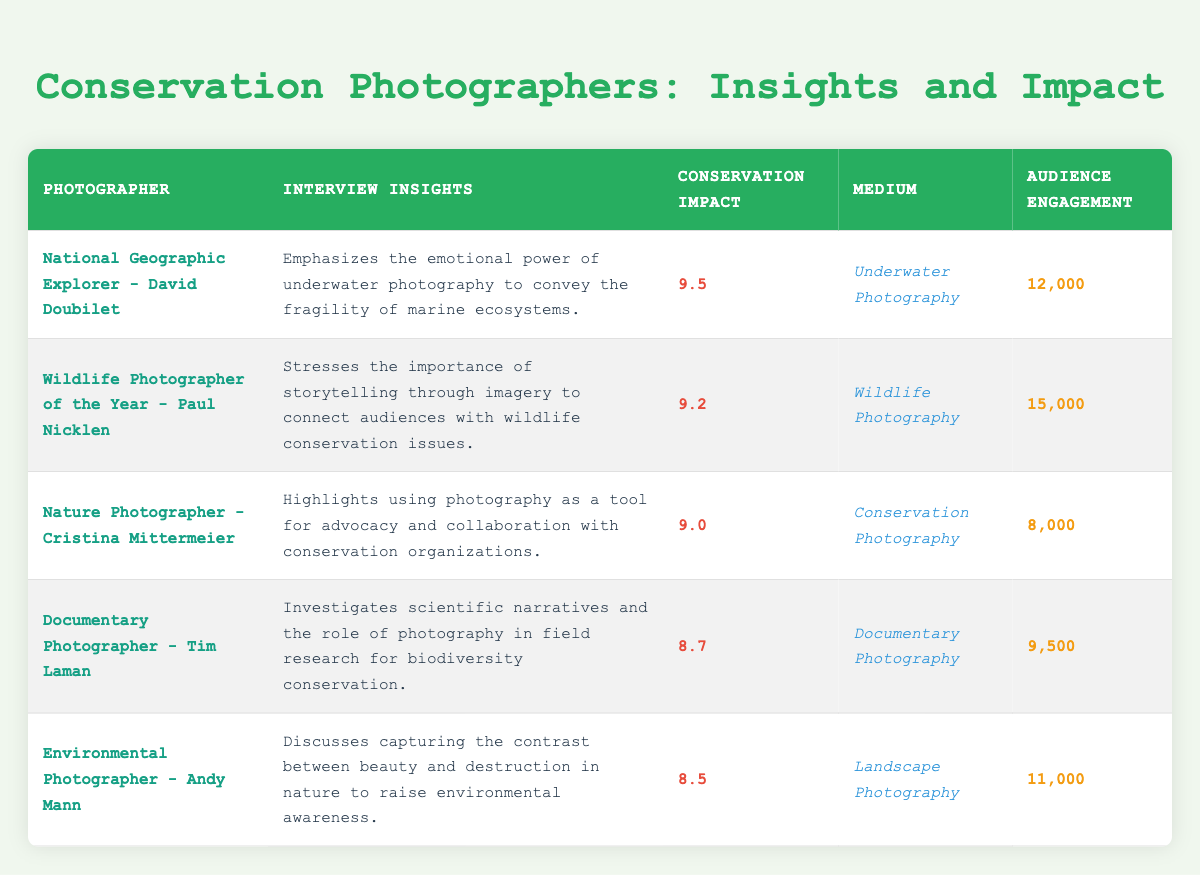What is the conservation awareness impact rating of David Doubilet? The data indicates that David Doubilet has a conservation awareness impact rating of 9.5. This information can be found directly within the "Conservation Awareness Impact Rating" column corresponding to his name in the table.
Answer: 9.5 Which medium used by Paul Nicklen received a higher impact rating: Wildlife Photography or Conservation Photography? Paul Nicklen’s medium is "Wildlife Photography" with an impact rating of 9.2, while Cristina Mittermeier uses "Conservation Photography" with an impact rating of 9.0. Comparing these values, Wildlife Photography has a higher rating than Conservation Photography.
Answer: Wildlife Photography How many more audience engagements does Andy Mann have than Cristina Mittermeier? Andy Mann has an audience engagement of 11,000, and Cristina Mittermeier has 8,000. To find the difference, subtract 8,000 from 11,000, which results in 3,000.
Answer: 3,000 Is it true that all featured photographers have a conservation awareness impact rating of at least 8.0? The impact ratings from the table show that the lowest rating is Andy Mann at 8.5, and all others are higher: 9.5, 9.2, 9.0, and 8.7. Since no rating is below 8.0, the statement is true.
Answer: Yes What is the average conservation awareness impact rating of the featured photographers? To calculate the average, sum the ratings: 9.5 + 9.2 + 9.0 + 8.7 + 8.5 = 44.9. Then divide by the number of photographers (5): 44.9 / 5 = 8.98.
Answer: 8.98 